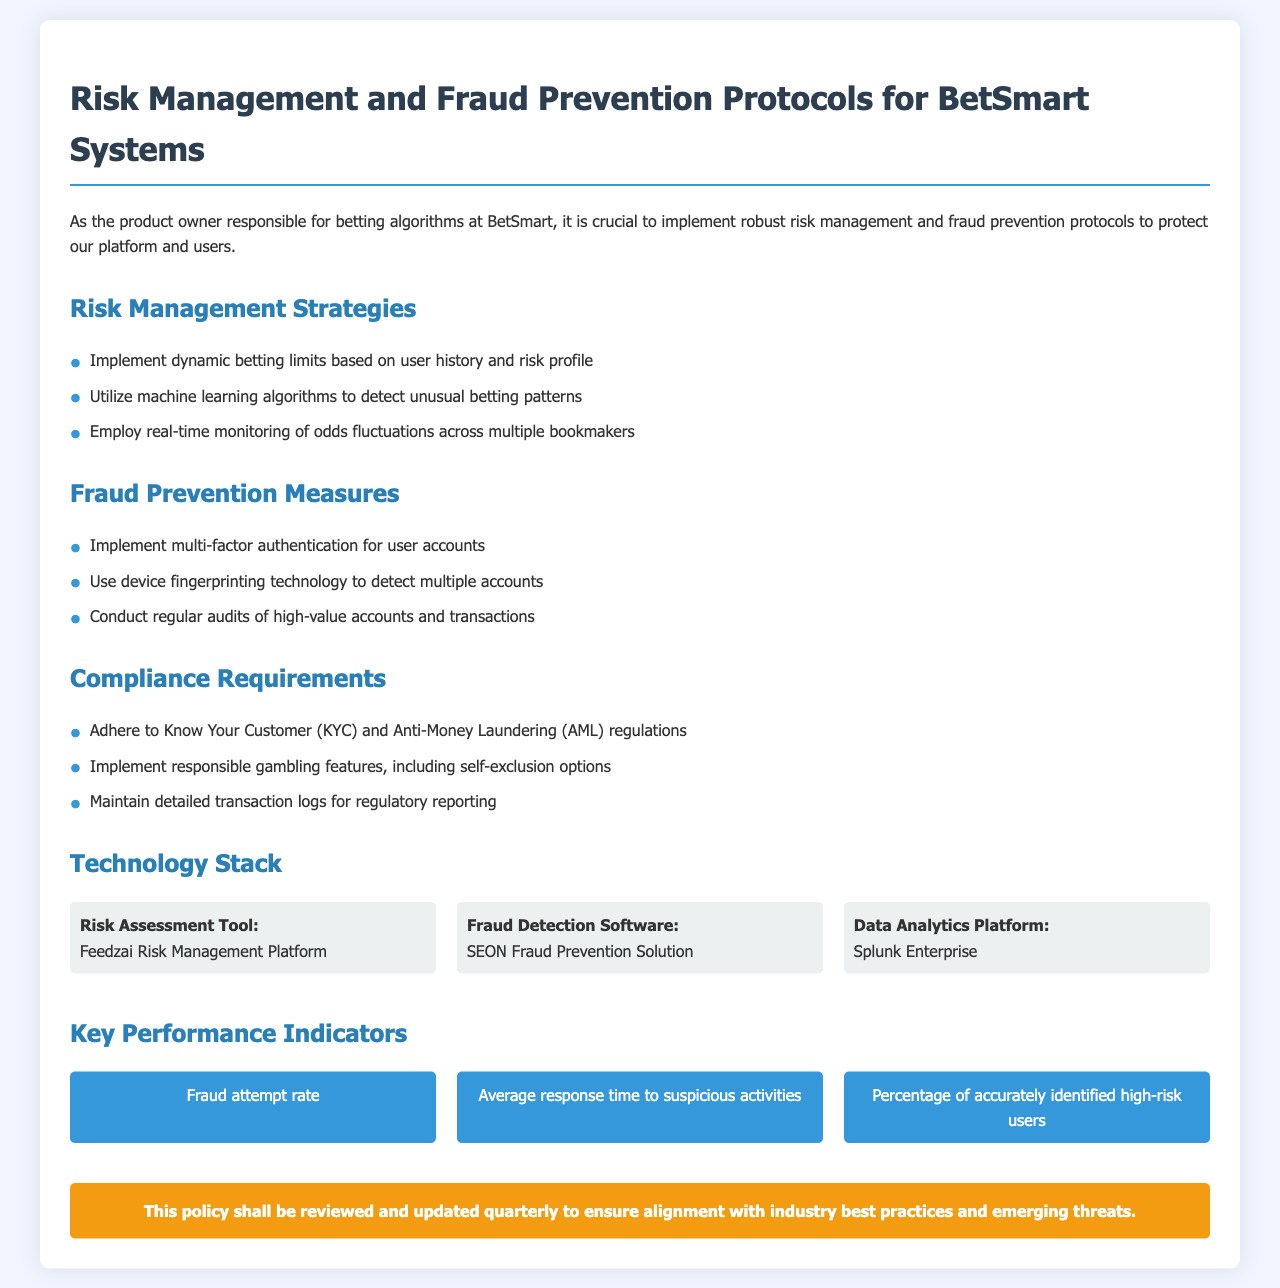what are the main risks addressed in the document? The document outlines Risk Management Strategies and Fraud Prevention Measures as the main areas of focus regarding risks.
Answer: Risk Management Strategies and Fraud Prevention Measures what technology is used for risk assessment? The document specifies "Feedzai Risk Management Platform" as the tool for risk assessment.
Answer: Feedzai Risk Management Platform how often will the policy be reviewed? The document states that the policy shall be reviewed and updated quarterly.
Answer: quarterly which regulation does the policy adhere to? The document mentions adherence to Know Your Customer (KYC) regulations as part of compliance requirements.
Answer: Know Your Customer (KYC) what is one of the key performance indicators? The document lists the "Fraud attempt rate" as one of the key performance indicators.
Answer: Fraud attempt rate what is a fraud prevention measure mentioned? The document states "Implement multi-factor authentication for user accounts" as a fraud prevention measure.
Answer: Implement multi-factor authentication for user accounts what is the purpose of the machine learning algorithms according to the document? The machine learning algorithms are utilized to detect unusual betting patterns as stated in the Risk Management Strategies.
Answer: detect unusual betting patterns what is one of the compliance requirements? The document lists "Maintain detailed transaction logs for regulatory reporting" as a compliance requirement.
Answer: Maintain detailed transaction logs for regulatory reporting 